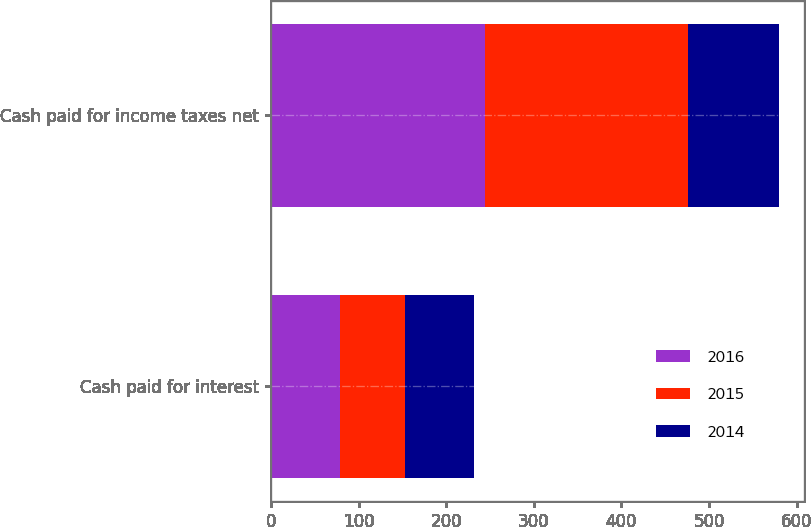Convert chart. <chart><loc_0><loc_0><loc_500><loc_500><stacked_bar_chart><ecel><fcel>Cash paid for interest<fcel>Cash paid for income taxes net<nl><fcel>2016<fcel>78.8<fcel>244.1<nl><fcel>2015<fcel>74.5<fcel>231.9<nl><fcel>2014<fcel>78.1<fcel>103.9<nl></chart> 